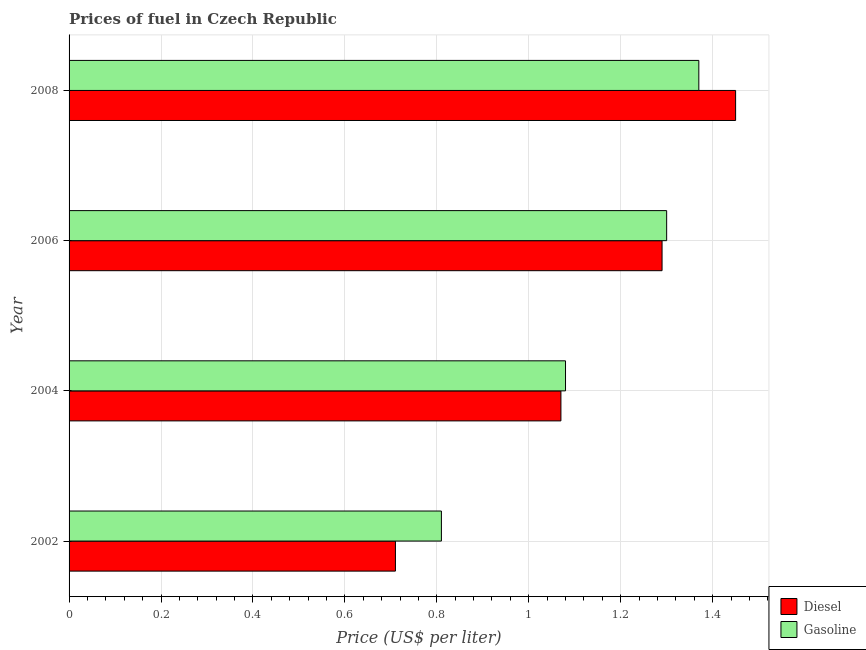Are the number of bars per tick equal to the number of legend labels?
Give a very brief answer. Yes. How many bars are there on the 4th tick from the bottom?
Your answer should be compact. 2. What is the label of the 2nd group of bars from the top?
Your response must be concise. 2006. What is the gasoline price in 2008?
Offer a very short reply. 1.37. Across all years, what is the maximum gasoline price?
Give a very brief answer. 1.37. Across all years, what is the minimum gasoline price?
Provide a succinct answer. 0.81. What is the total gasoline price in the graph?
Your answer should be very brief. 4.56. What is the difference between the gasoline price in 2002 and that in 2006?
Provide a short and direct response. -0.49. What is the difference between the gasoline price in 2008 and the diesel price in 2002?
Provide a succinct answer. 0.66. What is the average gasoline price per year?
Make the answer very short. 1.14. In the year 2008, what is the difference between the diesel price and gasoline price?
Your answer should be very brief. 0.08. In how many years, is the diesel price greater than 1.4800000000000002 US$ per litre?
Provide a succinct answer. 0. What is the ratio of the gasoline price in 2004 to that in 2006?
Make the answer very short. 0.83. Is the diesel price in 2004 less than that in 2006?
Your response must be concise. Yes. What is the difference between the highest and the second highest diesel price?
Offer a very short reply. 0.16. What is the difference between the highest and the lowest gasoline price?
Your answer should be compact. 0.56. In how many years, is the diesel price greater than the average diesel price taken over all years?
Provide a succinct answer. 2. What does the 2nd bar from the top in 2006 represents?
Keep it short and to the point. Diesel. What does the 1st bar from the bottom in 2004 represents?
Provide a succinct answer. Diesel. How many bars are there?
Your answer should be very brief. 8. How many years are there in the graph?
Provide a short and direct response. 4. Does the graph contain any zero values?
Provide a short and direct response. No. Does the graph contain grids?
Offer a very short reply. Yes. How many legend labels are there?
Provide a short and direct response. 2. What is the title of the graph?
Make the answer very short. Prices of fuel in Czech Republic. What is the label or title of the X-axis?
Keep it short and to the point. Price (US$ per liter). What is the Price (US$ per liter) in Diesel in 2002?
Your answer should be compact. 0.71. What is the Price (US$ per liter) in Gasoline in 2002?
Make the answer very short. 0.81. What is the Price (US$ per liter) of Diesel in 2004?
Keep it short and to the point. 1.07. What is the Price (US$ per liter) in Gasoline in 2004?
Offer a terse response. 1.08. What is the Price (US$ per liter) of Diesel in 2006?
Ensure brevity in your answer.  1.29. What is the Price (US$ per liter) of Diesel in 2008?
Keep it short and to the point. 1.45. What is the Price (US$ per liter) of Gasoline in 2008?
Give a very brief answer. 1.37. Across all years, what is the maximum Price (US$ per liter) of Diesel?
Your response must be concise. 1.45. Across all years, what is the maximum Price (US$ per liter) of Gasoline?
Provide a short and direct response. 1.37. Across all years, what is the minimum Price (US$ per liter) of Diesel?
Give a very brief answer. 0.71. Across all years, what is the minimum Price (US$ per liter) in Gasoline?
Keep it short and to the point. 0.81. What is the total Price (US$ per liter) in Diesel in the graph?
Your response must be concise. 4.52. What is the total Price (US$ per liter) in Gasoline in the graph?
Provide a short and direct response. 4.56. What is the difference between the Price (US$ per liter) of Diesel in 2002 and that in 2004?
Provide a short and direct response. -0.36. What is the difference between the Price (US$ per liter) of Gasoline in 2002 and that in 2004?
Your response must be concise. -0.27. What is the difference between the Price (US$ per liter) of Diesel in 2002 and that in 2006?
Keep it short and to the point. -0.58. What is the difference between the Price (US$ per liter) of Gasoline in 2002 and that in 2006?
Your response must be concise. -0.49. What is the difference between the Price (US$ per liter) in Diesel in 2002 and that in 2008?
Offer a very short reply. -0.74. What is the difference between the Price (US$ per liter) of Gasoline in 2002 and that in 2008?
Provide a short and direct response. -0.56. What is the difference between the Price (US$ per liter) of Diesel in 2004 and that in 2006?
Keep it short and to the point. -0.22. What is the difference between the Price (US$ per liter) of Gasoline in 2004 and that in 2006?
Your answer should be compact. -0.22. What is the difference between the Price (US$ per liter) in Diesel in 2004 and that in 2008?
Provide a succinct answer. -0.38. What is the difference between the Price (US$ per liter) in Gasoline in 2004 and that in 2008?
Make the answer very short. -0.29. What is the difference between the Price (US$ per liter) of Diesel in 2006 and that in 2008?
Offer a terse response. -0.16. What is the difference between the Price (US$ per liter) of Gasoline in 2006 and that in 2008?
Your answer should be compact. -0.07. What is the difference between the Price (US$ per liter) of Diesel in 2002 and the Price (US$ per liter) of Gasoline in 2004?
Offer a very short reply. -0.37. What is the difference between the Price (US$ per liter) of Diesel in 2002 and the Price (US$ per liter) of Gasoline in 2006?
Your response must be concise. -0.59. What is the difference between the Price (US$ per liter) in Diesel in 2002 and the Price (US$ per liter) in Gasoline in 2008?
Your answer should be compact. -0.66. What is the difference between the Price (US$ per liter) of Diesel in 2004 and the Price (US$ per liter) of Gasoline in 2006?
Your answer should be compact. -0.23. What is the difference between the Price (US$ per liter) of Diesel in 2004 and the Price (US$ per liter) of Gasoline in 2008?
Provide a succinct answer. -0.3. What is the difference between the Price (US$ per liter) in Diesel in 2006 and the Price (US$ per liter) in Gasoline in 2008?
Your response must be concise. -0.08. What is the average Price (US$ per liter) of Diesel per year?
Offer a terse response. 1.13. What is the average Price (US$ per liter) in Gasoline per year?
Your answer should be compact. 1.14. In the year 2002, what is the difference between the Price (US$ per liter) in Diesel and Price (US$ per liter) in Gasoline?
Your answer should be very brief. -0.1. In the year 2004, what is the difference between the Price (US$ per liter) in Diesel and Price (US$ per liter) in Gasoline?
Offer a terse response. -0.01. In the year 2006, what is the difference between the Price (US$ per liter) in Diesel and Price (US$ per liter) in Gasoline?
Provide a succinct answer. -0.01. In the year 2008, what is the difference between the Price (US$ per liter) of Diesel and Price (US$ per liter) of Gasoline?
Give a very brief answer. 0.08. What is the ratio of the Price (US$ per liter) in Diesel in 2002 to that in 2004?
Your answer should be very brief. 0.66. What is the ratio of the Price (US$ per liter) of Gasoline in 2002 to that in 2004?
Offer a terse response. 0.75. What is the ratio of the Price (US$ per liter) in Diesel in 2002 to that in 2006?
Your answer should be very brief. 0.55. What is the ratio of the Price (US$ per liter) of Gasoline in 2002 to that in 2006?
Offer a very short reply. 0.62. What is the ratio of the Price (US$ per liter) in Diesel in 2002 to that in 2008?
Make the answer very short. 0.49. What is the ratio of the Price (US$ per liter) in Gasoline in 2002 to that in 2008?
Offer a very short reply. 0.59. What is the ratio of the Price (US$ per liter) in Diesel in 2004 to that in 2006?
Your answer should be very brief. 0.83. What is the ratio of the Price (US$ per liter) of Gasoline in 2004 to that in 2006?
Make the answer very short. 0.83. What is the ratio of the Price (US$ per liter) of Diesel in 2004 to that in 2008?
Keep it short and to the point. 0.74. What is the ratio of the Price (US$ per liter) of Gasoline in 2004 to that in 2008?
Make the answer very short. 0.79. What is the ratio of the Price (US$ per liter) of Diesel in 2006 to that in 2008?
Give a very brief answer. 0.89. What is the ratio of the Price (US$ per liter) in Gasoline in 2006 to that in 2008?
Offer a terse response. 0.95. What is the difference between the highest and the second highest Price (US$ per liter) of Diesel?
Provide a short and direct response. 0.16. What is the difference between the highest and the second highest Price (US$ per liter) in Gasoline?
Ensure brevity in your answer.  0.07. What is the difference between the highest and the lowest Price (US$ per liter) of Diesel?
Keep it short and to the point. 0.74. What is the difference between the highest and the lowest Price (US$ per liter) in Gasoline?
Keep it short and to the point. 0.56. 